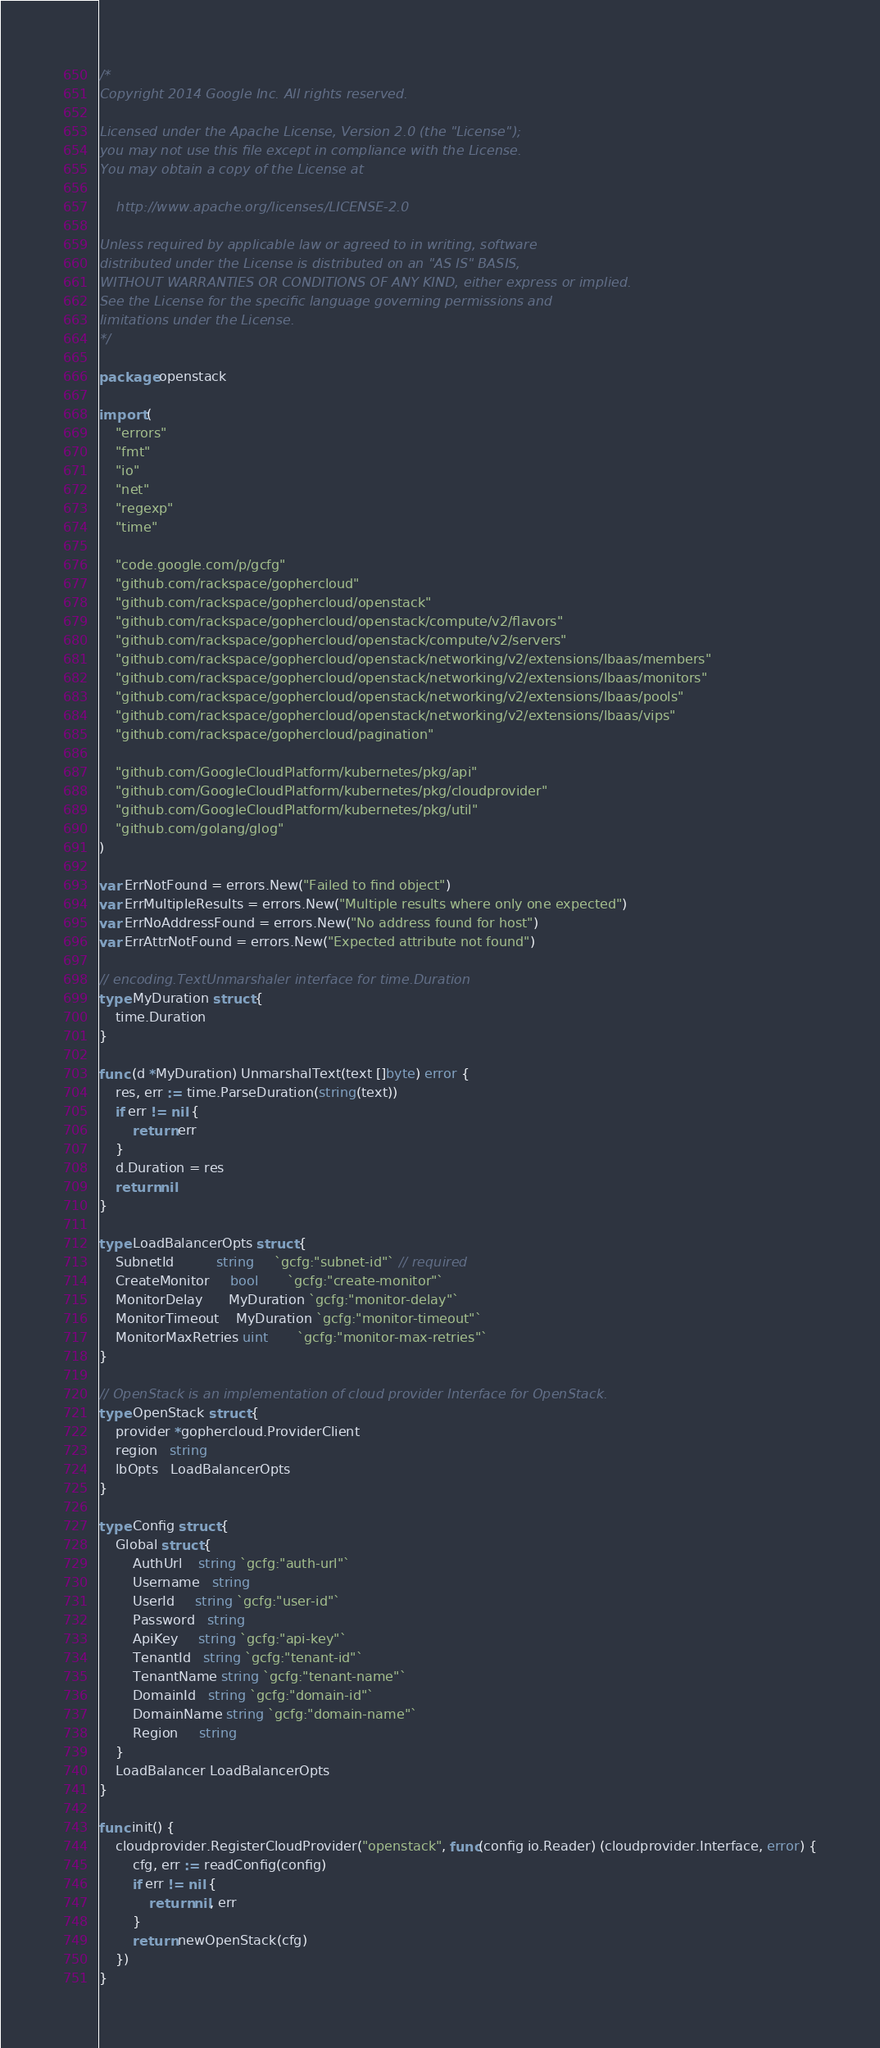<code> <loc_0><loc_0><loc_500><loc_500><_Go_>/*
Copyright 2014 Google Inc. All rights reserved.

Licensed under the Apache License, Version 2.0 (the "License");
you may not use this file except in compliance with the License.
You may obtain a copy of the License at

    http://www.apache.org/licenses/LICENSE-2.0

Unless required by applicable law or agreed to in writing, software
distributed under the License is distributed on an "AS IS" BASIS,
WITHOUT WARRANTIES OR CONDITIONS OF ANY KIND, either express or implied.
See the License for the specific language governing permissions and
limitations under the License.
*/

package openstack

import (
	"errors"
	"fmt"
	"io"
	"net"
	"regexp"
	"time"

	"code.google.com/p/gcfg"
	"github.com/rackspace/gophercloud"
	"github.com/rackspace/gophercloud/openstack"
	"github.com/rackspace/gophercloud/openstack/compute/v2/flavors"
	"github.com/rackspace/gophercloud/openstack/compute/v2/servers"
	"github.com/rackspace/gophercloud/openstack/networking/v2/extensions/lbaas/members"
	"github.com/rackspace/gophercloud/openstack/networking/v2/extensions/lbaas/monitors"
	"github.com/rackspace/gophercloud/openstack/networking/v2/extensions/lbaas/pools"
	"github.com/rackspace/gophercloud/openstack/networking/v2/extensions/lbaas/vips"
	"github.com/rackspace/gophercloud/pagination"

	"github.com/GoogleCloudPlatform/kubernetes/pkg/api"
	"github.com/GoogleCloudPlatform/kubernetes/pkg/cloudprovider"
	"github.com/GoogleCloudPlatform/kubernetes/pkg/util"
	"github.com/golang/glog"
)

var ErrNotFound = errors.New("Failed to find object")
var ErrMultipleResults = errors.New("Multiple results where only one expected")
var ErrNoAddressFound = errors.New("No address found for host")
var ErrAttrNotFound = errors.New("Expected attribute not found")

// encoding.TextUnmarshaler interface for time.Duration
type MyDuration struct {
	time.Duration
}

func (d *MyDuration) UnmarshalText(text []byte) error {
	res, err := time.ParseDuration(string(text))
	if err != nil {
		return err
	}
	d.Duration = res
	return nil
}

type LoadBalancerOpts struct {
	SubnetId          string     `gcfg:"subnet-id"` // required
	CreateMonitor     bool       `gcfg:"create-monitor"`
	MonitorDelay      MyDuration `gcfg:"monitor-delay"`
	MonitorTimeout    MyDuration `gcfg:"monitor-timeout"`
	MonitorMaxRetries uint       `gcfg:"monitor-max-retries"`
}

// OpenStack is an implementation of cloud provider Interface for OpenStack.
type OpenStack struct {
	provider *gophercloud.ProviderClient
	region   string
	lbOpts   LoadBalancerOpts
}

type Config struct {
	Global struct {
		AuthUrl    string `gcfg:"auth-url"`
		Username   string
		UserId     string `gcfg:"user-id"`
		Password   string
		ApiKey     string `gcfg:"api-key"`
		TenantId   string `gcfg:"tenant-id"`
		TenantName string `gcfg:"tenant-name"`
		DomainId   string `gcfg:"domain-id"`
		DomainName string `gcfg:"domain-name"`
		Region     string
	}
	LoadBalancer LoadBalancerOpts
}

func init() {
	cloudprovider.RegisterCloudProvider("openstack", func(config io.Reader) (cloudprovider.Interface, error) {
		cfg, err := readConfig(config)
		if err != nil {
			return nil, err
		}
		return newOpenStack(cfg)
	})
}
</code> 